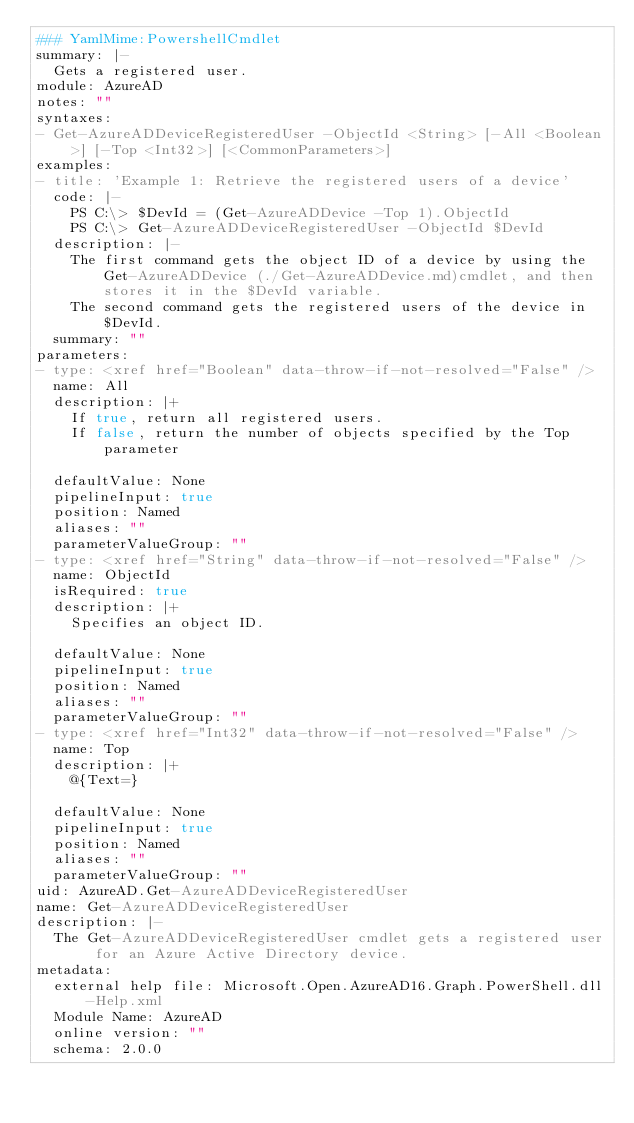<code> <loc_0><loc_0><loc_500><loc_500><_YAML_>### YamlMime:PowershellCmdlet
summary: |-
  Gets a registered user.
module: AzureAD
notes: ""
syntaxes:
- Get-AzureADDeviceRegisteredUser -ObjectId <String> [-All <Boolean>] [-Top <Int32>] [<CommonParameters>]
examples:
- title: 'Example 1: Retrieve the registered users of a device'
  code: |-
    PS C:\> $DevId = (Get-AzureADDevice -Top 1).ObjectId
    PS C:\> Get-AzureADDeviceRegisteredUser -ObjectId $DevId
  description: |-
    The first command gets the object ID of a device by using the Get-AzureADDevice (./Get-AzureADDevice.md)cmdlet, and then stores it in the $DevId variable.
    The second command gets the registered users of the device in $DevId.
  summary: ""
parameters:
- type: <xref href="Boolean" data-throw-if-not-resolved="False" />
  name: All
  description: |+
    If true, return all registered users.
    If false, return the number of objects specified by the Top parameter

  defaultValue: None
  pipelineInput: true
  position: Named
  aliases: ""
  parameterValueGroup: ""
- type: <xref href="String" data-throw-if-not-resolved="False" />
  name: ObjectId
  isRequired: true
  description: |+
    Specifies an object ID.

  defaultValue: None
  pipelineInput: true
  position: Named
  aliases: ""
  parameterValueGroup: ""
- type: <xref href="Int32" data-throw-if-not-resolved="False" />
  name: Top
  description: |+
    @{Text=}

  defaultValue: None
  pipelineInput: true
  position: Named
  aliases: ""
  parameterValueGroup: ""
uid: AzureAD.Get-AzureADDeviceRegisteredUser
name: Get-AzureADDeviceRegisteredUser
description: |-
  The Get-AzureADDeviceRegisteredUser cmdlet gets a registered user for an Azure Active Directory device.
metadata:
  external help file: Microsoft.Open.AzureAD16.Graph.PowerShell.dll-Help.xml
  Module Name: AzureAD
  online version: ""
  schema: 2.0.0
</code> 